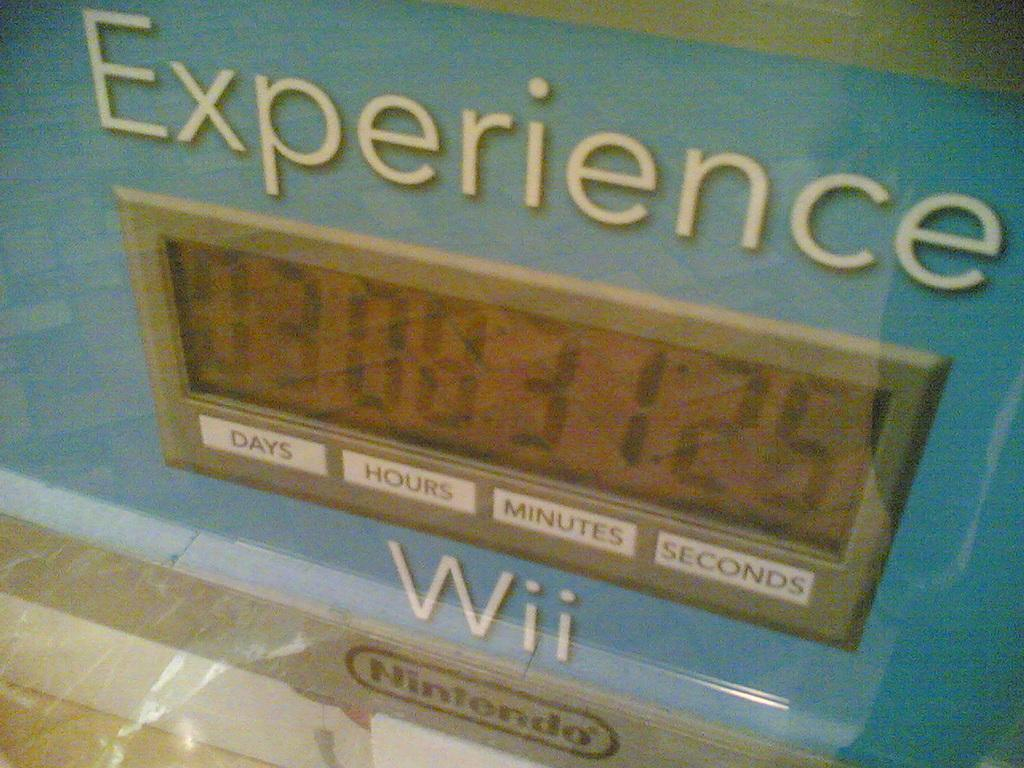<image>
Share a concise interpretation of the image provided. a Nintendo sign says to experience Wii, with a counter of days, hours and monutes 